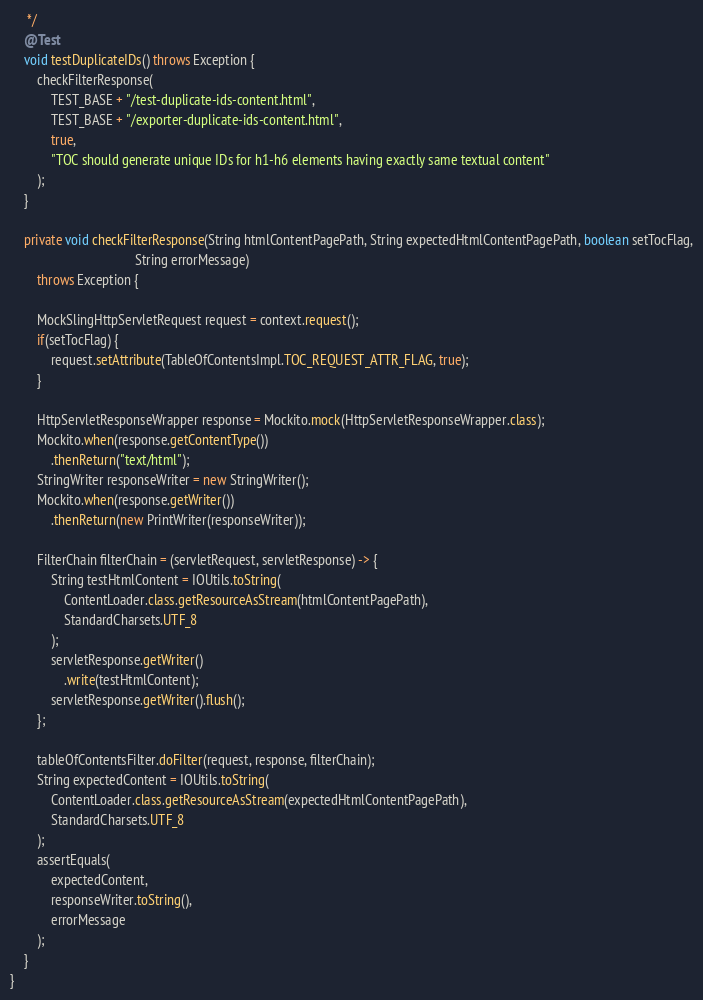<code> <loc_0><loc_0><loc_500><loc_500><_Java_>     */
    @Test
    void testDuplicateIDs() throws Exception {
        checkFilterResponse(
            TEST_BASE + "/test-duplicate-ids-content.html",
            TEST_BASE + "/exporter-duplicate-ids-content.html",
            true,
            "TOC should generate unique IDs for h1-h6 elements having exactly same textual content"
        );
    }

    private void checkFilterResponse(String htmlContentPagePath, String expectedHtmlContentPagePath, boolean setTocFlag,
                                     String errorMessage)
        throws Exception {

        MockSlingHttpServletRequest request = context.request();
        if(setTocFlag) {
            request.setAttribute(TableOfContentsImpl.TOC_REQUEST_ATTR_FLAG, true);
        }

        HttpServletResponseWrapper response = Mockito.mock(HttpServletResponseWrapper.class);
        Mockito.when(response.getContentType())
            .thenReturn("text/html");
        StringWriter responseWriter = new StringWriter();
        Mockito.when(response.getWriter())
            .thenReturn(new PrintWriter(responseWriter));

        FilterChain filterChain = (servletRequest, servletResponse) -> {
            String testHtmlContent = IOUtils.toString(
                ContentLoader.class.getResourceAsStream(htmlContentPagePath),
                StandardCharsets.UTF_8
            );
            servletResponse.getWriter()
                .write(testHtmlContent);
            servletResponse.getWriter().flush();
        };

        tableOfContentsFilter.doFilter(request, response, filterChain);
        String expectedContent = IOUtils.toString(
            ContentLoader.class.getResourceAsStream(expectedHtmlContentPagePath),
            StandardCharsets.UTF_8
        );
        assertEquals(
            expectedContent,
            responseWriter.toString(),
            errorMessage
        );
    }
}
</code> 